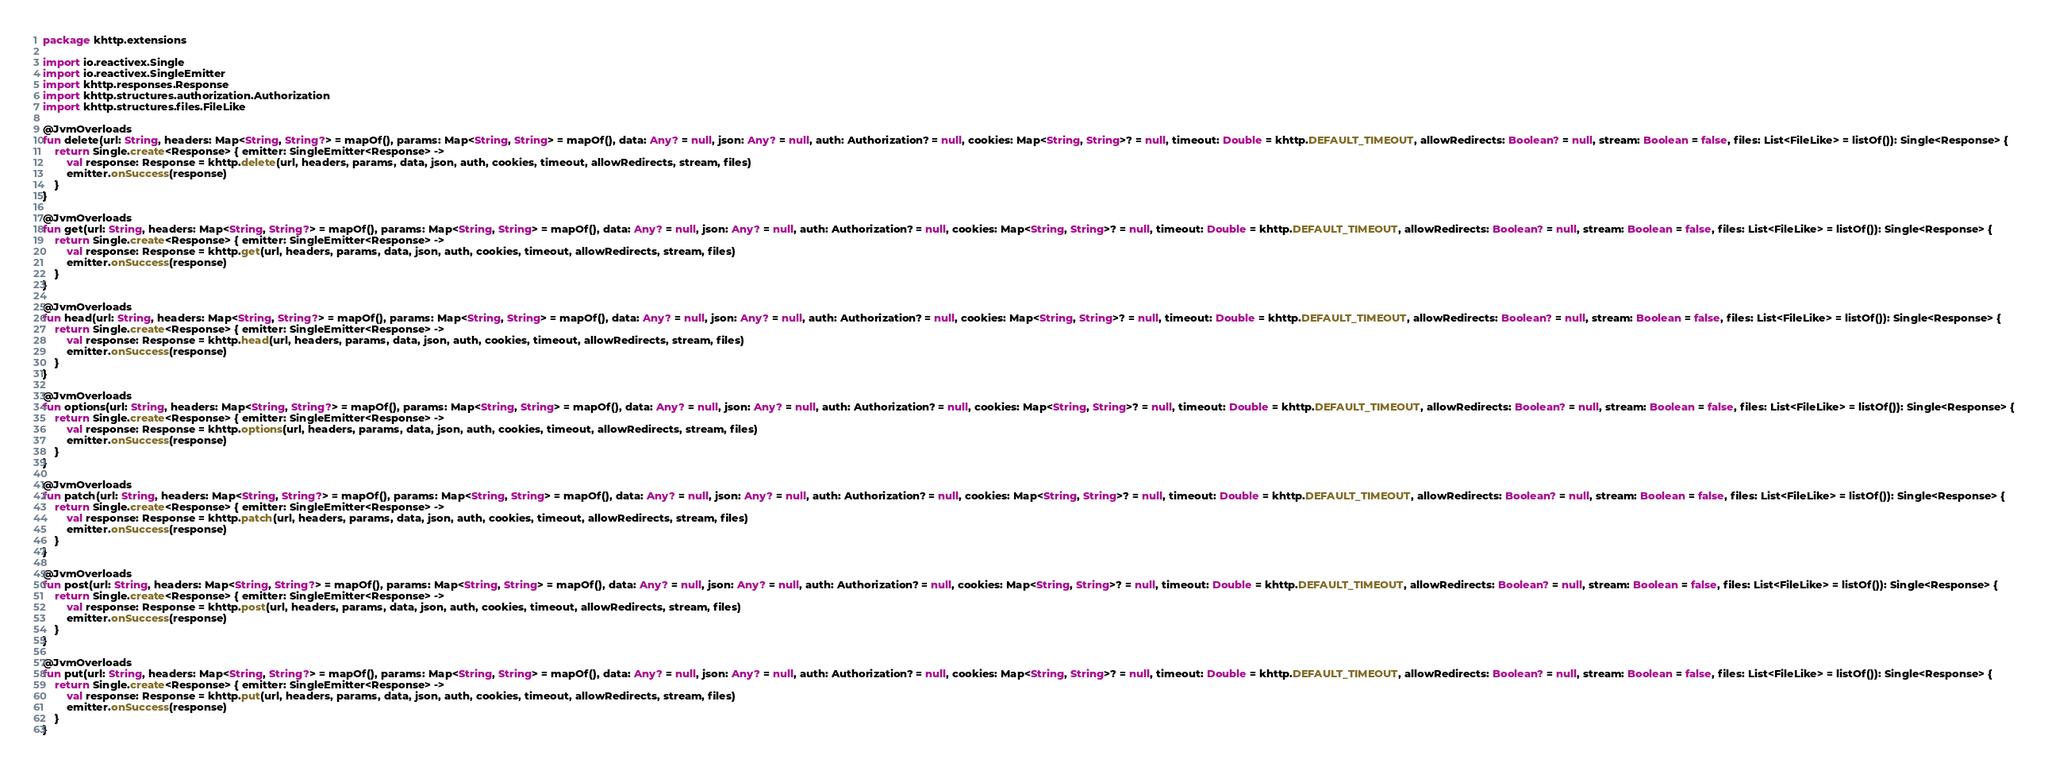Convert code to text. <code><loc_0><loc_0><loc_500><loc_500><_Kotlin_>package khttp.extensions

import io.reactivex.Single
import io.reactivex.SingleEmitter
import khttp.responses.Response
import khttp.structures.authorization.Authorization
import khttp.structures.files.FileLike

@JvmOverloads
fun delete(url: String, headers: Map<String, String?> = mapOf(), params: Map<String, String> = mapOf(), data: Any? = null, json: Any? = null, auth: Authorization? = null, cookies: Map<String, String>? = null, timeout: Double = khttp.DEFAULT_TIMEOUT, allowRedirects: Boolean? = null, stream: Boolean = false, files: List<FileLike> = listOf()): Single<Response> {
    return Single.create<Response> { emitter: SingleEmitter<Response> ->
        val response: Response = khttp.delete(url, headers, params, data, json, auth, cookies, timeout, allowRedirects, stream, files)
        emitter.onSuccess(response)
    }
}

@JvmOverloads
fun get(url: String, headers: Map<String, String?> = mapOf(), params: Map<String, String> = mapOf(), data: Any? = null, json: Any? = null, auth: Authorization? = null, cookies: Map<String, String>? = null, timeout: Double = khttp.DEFAULT_TIMEOUT, allowRedirects: Boolean? = null, stream: Boolean = false, files: List<FileLike> = listOf()): Single<Response> {
    return Single.create<Response> { emitter: SingleEmitter<Response> ->
        val response: Response = khttp.get(url, headers, params, data, json, auth, cookies, timeout, allowRedirects, stream, files)
        emitter.onSuccess(response)
    }
}

@JvmOverloads
fun head(url: String, headers: Map<String, String?> = mapOf(), params: Map<String, String> = mapOf(), data: Any? = null, json: Any? = null, auth: Authorization? = null, cookies: Map<String, String>? = null, timeout: Double = khttp.DEFAULT_TIMEOUT, allowRedirects: Boolean? = null, stream: Boolean = false, files: List<FileLike> = listOf()): Single<Response> {
    return Single.create<Response> { emitter: SingleEmitter<Response> ->
        val response: Response = khttp.head(url, headers, params, data, json, auth, cookies, timeout, allowRedirects, stream, files)
        emitter.onSuccess(response)
    }
}

@JvmOverloads
fun options(url: String, headers: Map<String, String?> = mapOf(), params: Map<String, String> = mapOf(), data: Any? = null, json: Any? = null, auth: Authorization? = null, cookies: Map<String, String>? = null, timeout: Double = khttp.DEFAULT_TIMEOUT, allowRedirects: Boolean? = null, stream: Boolean = false, files: List<FileLike> = listOf()): Single<Response> {
    return Single.create<Response> { emitter: SingleEmitter<Response> ->
        val response: Response = khttp.options(url, headers, params, data, json, auth, cookies, timeout, allowRedirects, stream, files)
        emitter.onSuccess(response)
    }
}

@JvmOverloads
fun patch(url: String, headers: Map<String, String?> = mapOf(), params: Map<String, String> = mapOf(), data: Any? = null, json: Any? = null, auth: Authorization? = null, cookies: Map<String, String>? = null, timeout: Double = khttp.DEFAULT_TIMEOUT, allowRedirects: Boolean? = null, stream: Boolean = false, files: List<FileLike> = listOf()): Single<Response> {
    return Single.create<Response> { emitter: SingleEmitter<Response> ->
        val response: Response = khttp.patch(url, headers, params, data, json, auth, cookies, timeout, allowRedirects, stream, files)
        emitter.onSuccess(response)
    }
}

@JvmOverloads
fun post(url: String, headers: Map<String, String?> = mapOf(), params: Map<String, String> = mapOf(), data: Any? = null, json: Any? = null, auth: Authorization? = null, cookies: Map<String, String>? = null, timeout: Double = khttp.DEFAULT_TIMEOUT, allowRedirects: Boolean? = null, stream: Boolean = false, files: List<FileLike> = listOf()): Single<Response> {
    return Single.create<Response> { emitter: SingleEmitter<Response> ->
        val response: Response = khttp.post(url, headers, params, data, json, auth, cookies, timeout, allowRedirects, stream, files)
        emitter.onSuccess(response)
    }
}

@JvmOverloads
fun put(url: String, headers: Map<String, String?> = mapOf(), params: Map<String, String> = mapOf(), data: Any? = null, json: Any? = null, auth: Authorization? = null, cookies: Map<String, String>? = null, timeout: Double = khttp.DEFAULT_TIMEOUT, allowRedirects: Boolean? = null, stream: Boolean = false, files: List<FileLike> = listOf()): Single<Response> {
    return Single.create<Response> { emitter: SingleEmitter<Response> ->
        val response: Response = khttp.put(url, headers, params, data, json, auth, cookies, timeout, allowRedirects, stream, files)
        emitter.onSuccess(response)
    }
}</code> 